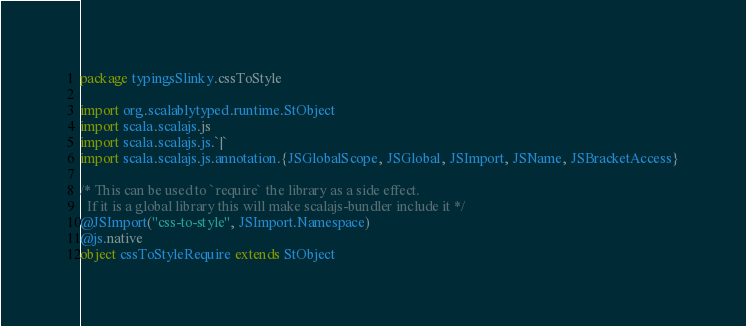Convert code to text. <code><loc_0><loc_0><loc_500><loc_500><_Scala_>package typingsSlinky.cssToStyle

import org.scalablytyped.runtime.StObject
import scala.scalajs.js
import scala.scalajs.js.`|`
import scala.scalajs.js.annotation.{JSGlobalScope, JSGlobal, JSImport, JSName, JSBracketAccess}

/* This can be used to `require` the library as a side effect.
  If it is a global library this will make scalajs-bundler include it */
@JSImport("css-to-style", JSImport.Namespace)
@js.native
object cssToStyleRequire extends StObject
</code> 